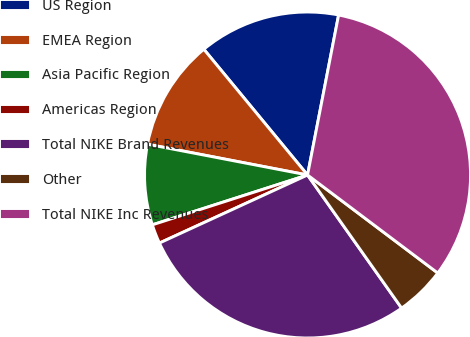Convert chart. <chart><loc_0><loc_0><loc_500><loc_500><pie_chart><fcel>US Region<fcel>EMEA Region<fcel>Asia Pacific Region<fcel>Americas Region<fcel>Total NIKE Brand Revenues<fcel>Other<fcel>Total NIKE Inc Revenues<nl><fcel>14.03%<fcel>11.0%<fcel>7.97%<fcel>1.91%<fcel>27.94%<fcel>4.94%<fcel>32.22%<nl></chart> 